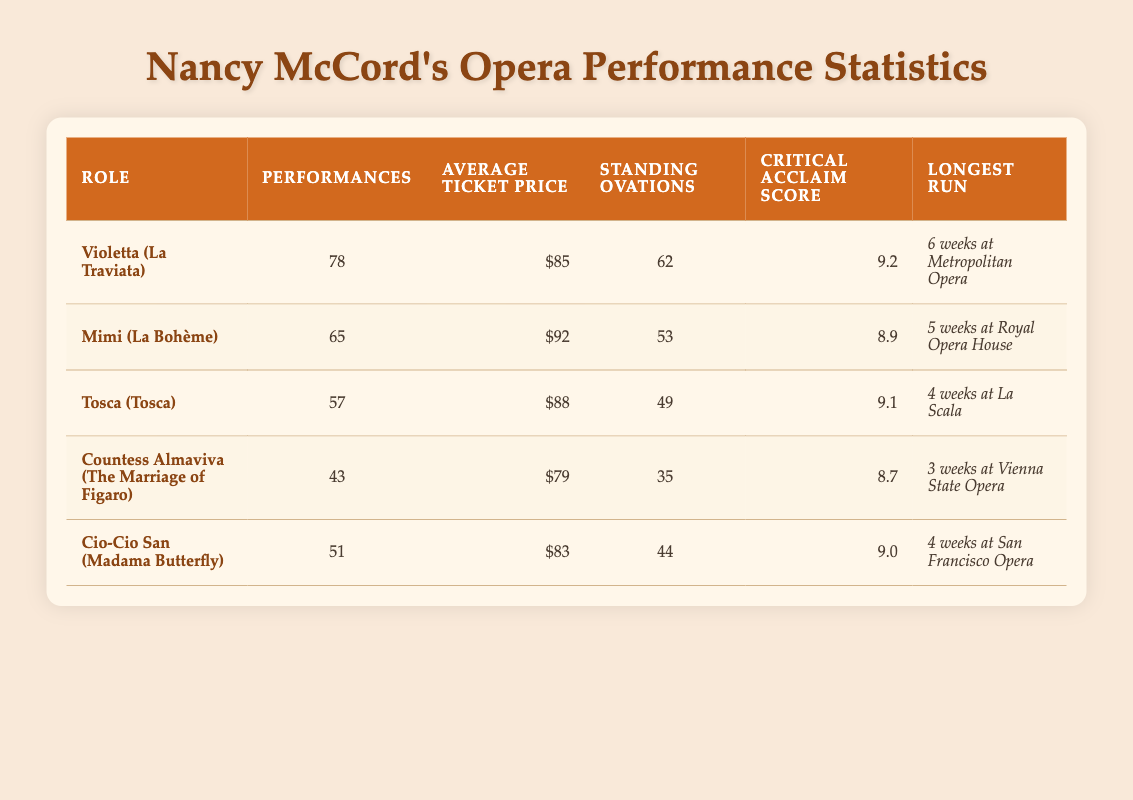What role had the highest number of performances? By looking at the "Performances" column, Violetta in "La Traviata" has the highest value of 78 performances compared to the other roles listed.
Answer: Violetta (La Traviata) What was the average ticket price for Mimi in La Bohème? The table states that the average ticket price for Mimi is shown as $92.
Answer: $92 Which role received the most standing ovations? Checking the "Standing Ovations" column, Violetta in "La Traviata" received the most standing ovations with a total of 62.
Answer: Violetta (La Traviata) What is the critical acclaim score of Countess Almaviva? The critical acclaim score for Countess Almaviva from the "Critical Acclaim Score" column is listed as 8.7.
Answer: 8.7 How many more performances did Violetta have compared to Tosca? Violetta had 78 performances while Tosca had 57 performances. The difference is calculated as 78 - 57 = 21 performances.
Answer: 21 Is the average ticket price for Cio-Cio San higher than that for Countess Almaviva? The average ticket price for Cio-Cio San is $83 and for Countess Almaviva is $79. Since $83 is greater than $79, the statement is true.
Answer: Yes What was the longest run for Mimi in La Bohème? The "Longest Run" for Mimi is recorded as 5 weeks at the Royal Opera House.
Answer: 5 weeks at Royal Opera House What is the average critical acclaim score across all roles? To find the average critical acclaim score, we need to sum the scores: 9.2 + 8.9 + 9.1 + 8.7 + 9.0 = 45.9. Then, dividing by the number of roles (5), we get 45.9 / 5 = 9.18, which can be rounded to two decimal places.
Answer: 9.18 How many standing ovations did Cio-Cio San receive? The standing ovations for Cio-Cio San is stated as 44 in the table.
Answer: 44 